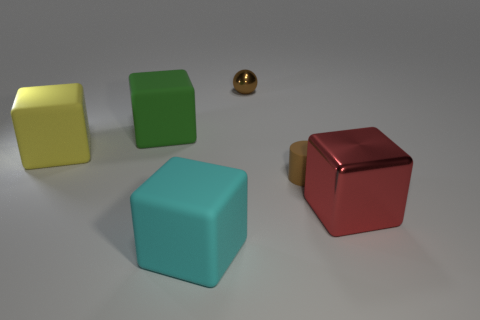Add 3 large brown matte spheres. How many objects exist? 9 Subtract all matte blocks. How many blocks are left? 1 Subtract all green cubes. How many cubes are left? 3 Subtract 1 cubes. How many cubes are left? 3 Subtract all big green matte cubes. Subtract all tiny brown spheres. How many objects are left? 4 Add 2 big matte blocks. How many big matte blocks are left? 5 Add 3 brown spheres. How many brown spheres exist? 4 Subtract 1 yellow cubes. How many objects are left? 5 Subtract all cubes. How many objects are left? 2 Subtract all red blocks. Subtract all cyan balls. How many blocks are left? 3 